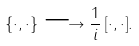Convert formula to latex. <formula><loc_0><loc_0><loc_500><loc_500>\{ \cdot , \cdot \} \longrightarrow \frac { 1 } { i } \, [ \cdot , \cdot ] .</formula> 